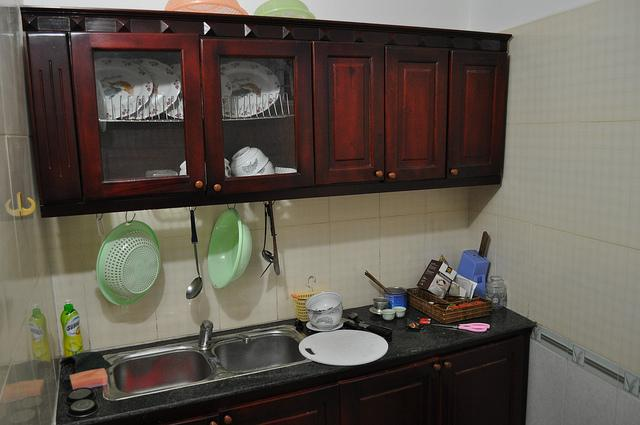What is the pink item on the counter? Please explain your reasoning. scissor handle. The pink item attaches to two cutting surfaces. spoons, forks, and napkins are not used to cut other things. 